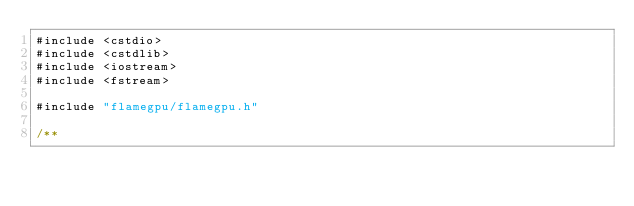Convert code to text. <code><loc_0><loc_0><loc_500><loc_500><_Cuda_>#include <cstdio>
#include <cstdlib>
#include <iostream>
#include <fstream>

#include "flamegpu/flamegpu.h"

/**</code> 